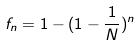Convert formula to latex. <formula><loc_0><loc_0><loc_500><loc_500>f _ { n } = 1 - ( 1 - \frac { 1 } { N } ) ^ { n }</formula> 